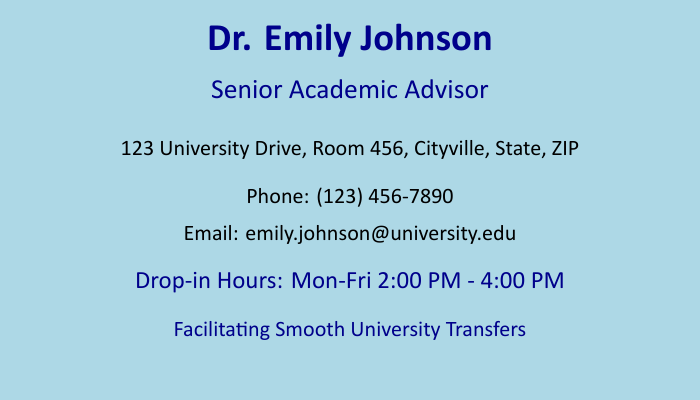What is the advisor's name? The advisor's name is clearly stated in the document as "Dr. Emily Johnson."
Answer: Dr. Emily Johnson What is the advisor's title? The document specifies the advisor's title as "Senior Academic Advisor."
Answer: Senior Academic Advisor What is the office address? The office address is indicated in the document: "123 University Drive, Room 456, Cityville, State, ZIP."
Answer: 123 University Drive, Room 456, Cityville, State, ZIP What is the phone number provided? The document lists the phone number as "(123) 456-7890."
Answer: (123) 456-7890 What are the drop-in hours? The drop-in hours specified in the document are "Mon-Fri 2:00 PM - 4:00 PM."
Answer: Mon-Fri 2:00 PM - 4:00 PM What is the purpose of this document? The document prominently states its purpose as "Facilitating Smooth University Transfers."
Answer: Facilitating Smooth University Transfers How many days a week are drop-in hours available? The document states drop-in hours are available Monday through Friday, which totals to 5 days a week.
Answer: 5 days What should I do to contact the advisor? To contact the advisor, you can either call the provided phone number or send an email to the given address.
Answer: Call or email What room number can I find the advisor in? The room number mentioned in the document is "Room 456."
Answer: Room 456 What color scheme is used in the document? The document features a light blue background with dark blue text.
Answer: Light blue and dark blue 